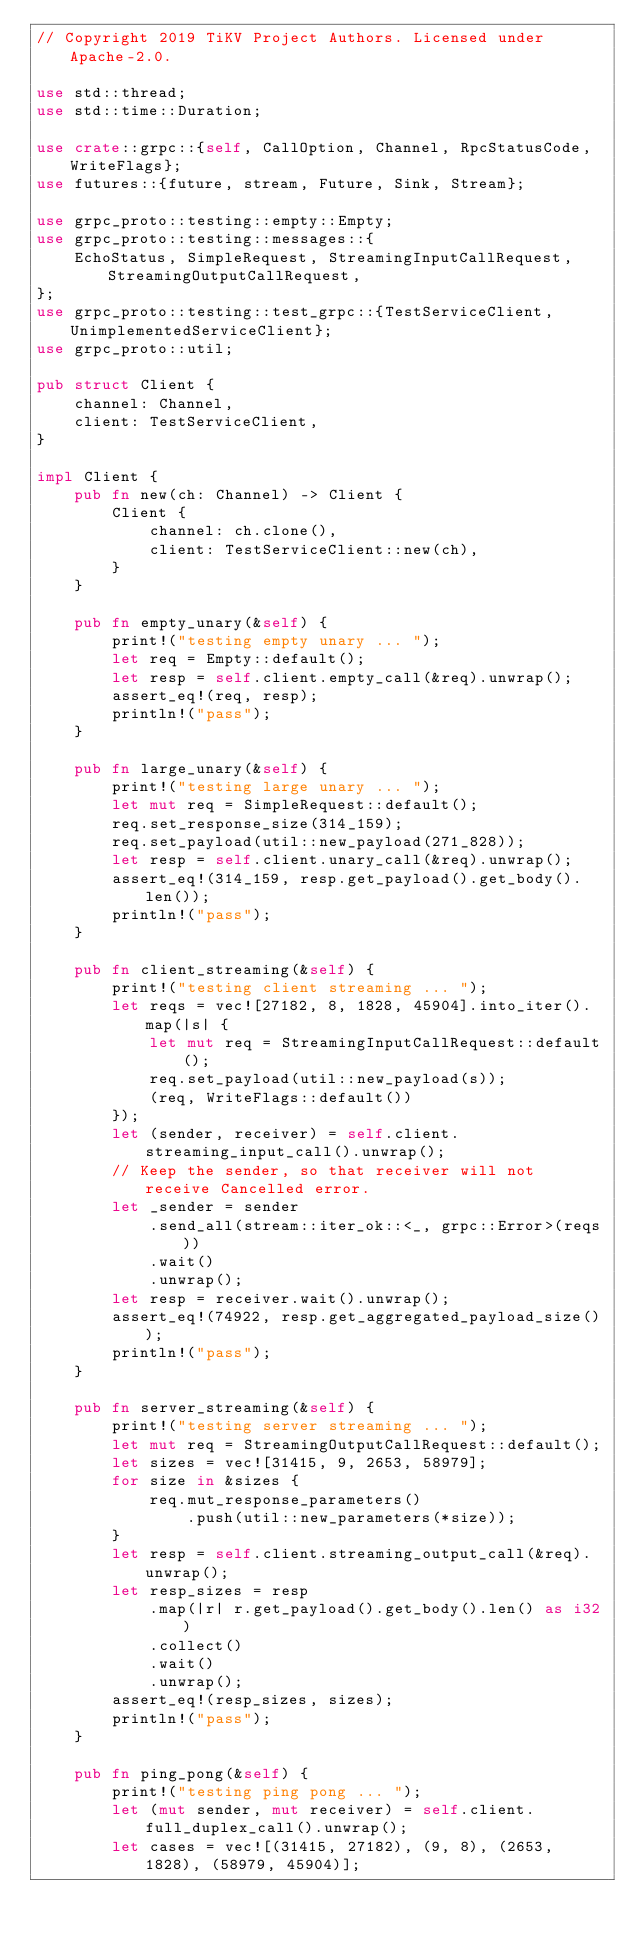Convert code to text. <code><loc_0><loc_0><loc_500><loc_500><_Rust_>// Copyright 2019 TiKV Project Authors. Licensed under Apache-2.0.

use std::thread;
use std::time::Duration;

use crate::grpc::{self, CallOption, Channel, RpcStatusCode, WriteFlags};
use futures::{future, stream, Future, Sink, Stream};

use grpc_proto::testing::empty::Empty;
use grpc_proto::testing::messages::{
    EchoStatus, SimpleRequest, StreamingInputCallRequest, StreamingOutputCallRequest,
};
use grpc_proto::testing::test_grpc::{TestServiceClient, UnimplementedServiceClient};
use grpc_proto::util;

pub struct Client {
    channel: Channel,
    client: TestServiceClient,
}

impl Client {
    pub fn new(ch: Channel) -> Client {
        Client {
            channel: ch.clone(),
            client: TestServiceClient::new(ch),
        }
    }

    pub fn empty_unary(&self) {
        print!("testing empty unary ... ");
        let req = Empty::default();
        let resp = self.client.empty_call(&req).unwrap();
        assert_eq!(req, resp);
        println!("pass");
    }

    pub fn large_unary(&self) {
        print!("testing large unary ... ");
        let mut req = SimpleRequest::default();
        req.set_response_size(314_159);
        req.set_payload(util::new_payload(271_828));
        let resp = self.client.unary_call(&req).unwrap();
        assert_eq!(314_159, resp.get_payload().get_body().len());
        println!("pass");
    }

    pub fn client_streaming(&self) {
        print!("testing client streaming ... ");
        let reqs = vec![27182, 8, 1828, 45904].into_iter().map(|s| {
            let mut req = StreamingInputCallRequest::default();
            req.set_payload(util::new_payload(s));
            (req, WriteFlags::default())
        });
        let (sender, receiver) = self.client.streaming_input_call().unwrap();
        // Keep the sender, so that receiver will not receive Cancelled error.
        let _sender = sender
            .send_all(stream::iter_ok::<_, grpc::Error>(reqs))
            .wait()
            .unwrap();
        let resp = receiver.wait().unwrap();
        assert_eq!(74922, resp.get_aggregated_payload_size());
        println!("pass");
    }

    pub fn server_streaming(&self) {
        print!("testing server streaming ... ");
        let mut req = StreamingOutputCallRequest::default();
        let sizes = vec![31415, 9, 2653, 58979];
        for size in &sizes {
            req.mut_response_parameters()
                .push(util::new_parameters(*size));
        }
        let resp = self.client.streaming_output_call(&req).unwrap();
        let resp_sizes = resp
            .map(|r| r.get_payload().get_body().len() as i32)
            .collect()
            .wait()
            .unwrap();
        assert_eq!(resp_sizes, sizes);
        println!("pass");
    }

    pub fn ping_pong(&self) {
        print!("testing ping pong ... ");
        let (mut sender, mut receiver) = self.client.full_duplex_call().unwrap();
        let cases = vec![(31415, 27182), (9, 8), (2653, 1828), (58979, 45904)];</code> 